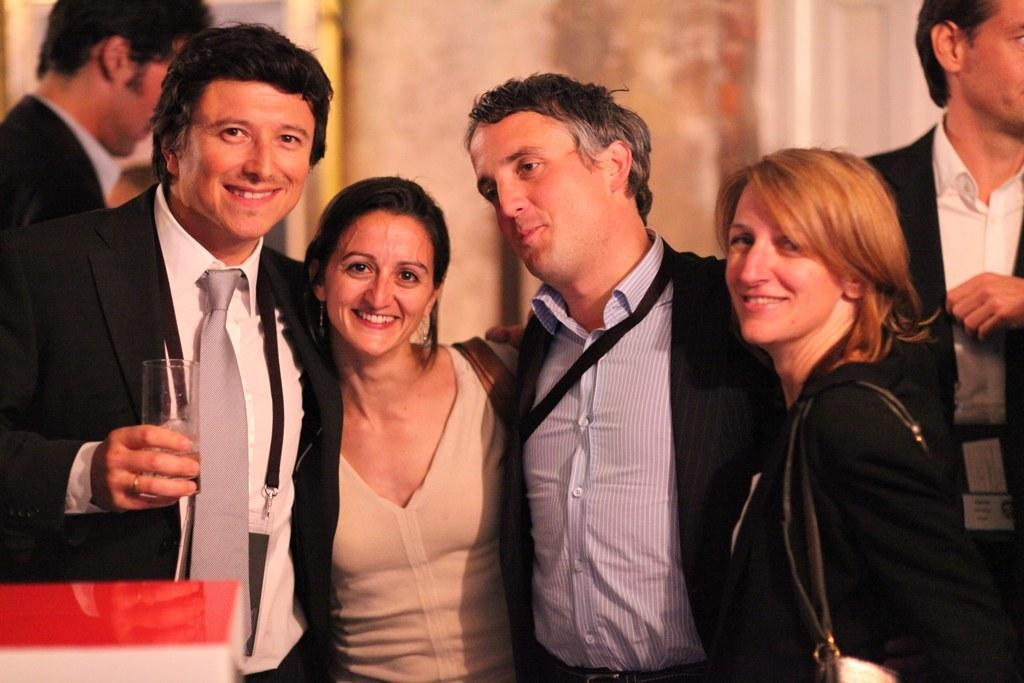What are the people in the image doing? People are standing in the image. Can you describe the clothing of the men in the image? The men in the image are wearing men's clothing. What object is being held by one of the people in the image? There is a person holding a glass in the image. How would you describe the background of the image? The background of the image is blurred. What type of nut is being discussed in the image? There is no nut or discussion about a nut present in the image. What news event is being reported in the image? There is no news event or reporting present in the image. 